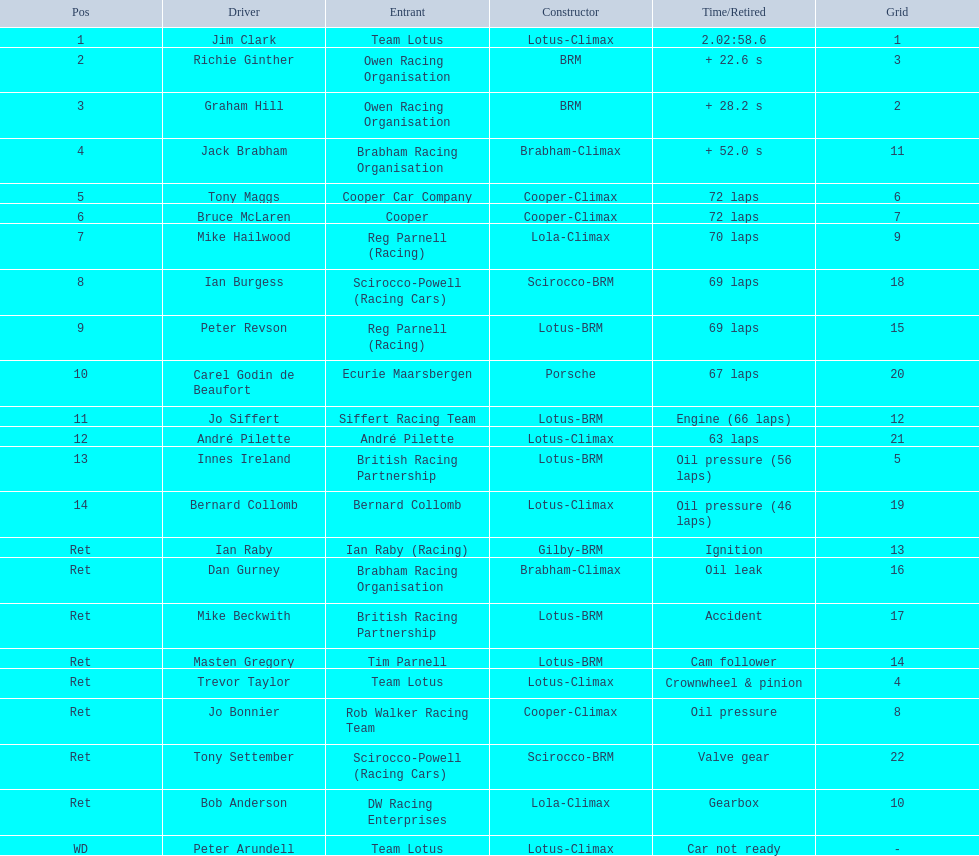Who are all the participants? Jim Clark, Richie Ginther, Graham Hill, Jack Brabham, Tony Maggs, Bruce McLaren, Mike Hailwood, Ian Burgess, Peter Revson, Carel Godin de Beaufort, Jo Siffert, André Pilette, Innes Ireland, Bernard Collomb, Ian Raby, Dan Gurney, Mike Beckwith, Masten Gregory, Trevor Taylor, Jo Bonnier, Tony Settember, Bob Anderson, Peter Arundell. Which piloted a cooper-climax? Tony Maggs, Bruce McLaren, Jo Bonnier. From them, who was the top placer? Tony Maggs. 